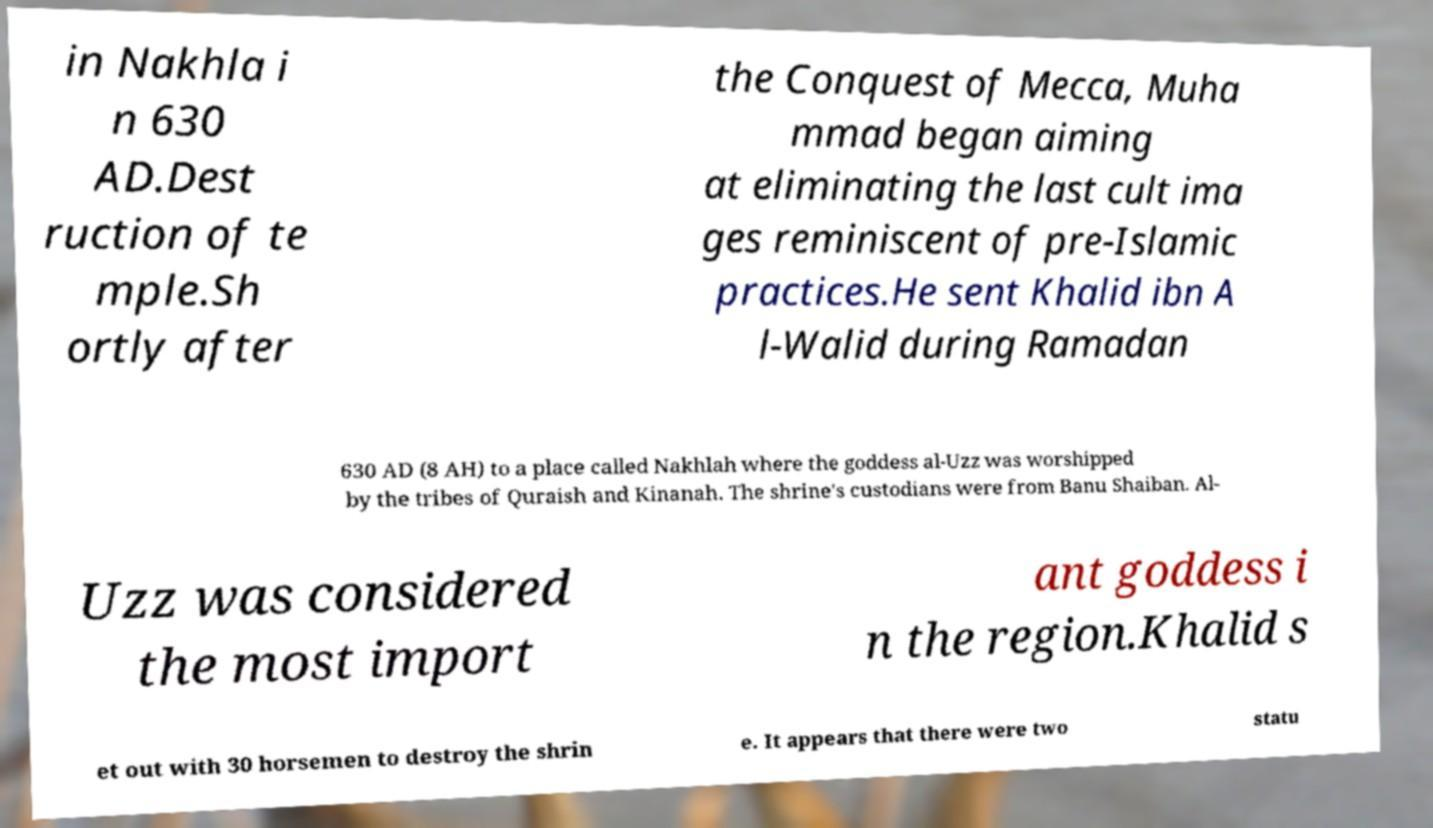Can you accurately transcribe the text from the provided image for me? in Nakhla i n 630 AD.Dest ruction of te mple.Sh ortly after the Conquest of Mecca, Muha mmad began aiming at eliminating the last cult ima ges reminiscent of pre-Islamic practices.He sent Khalid ibn A l-Walid during Ramadan 630 AD (8 AH) to a place called Nakhlah where the goddess al-Uzz was worshipped by the tribes of Quraish and Kinanah. The shrine's custodians were from Banu Shaiban. Al- Uzz was considered the most import ant goddess i n the region.Khalid s et out with 30 horsemen to destroy the shrin e. It appears that there were two statu 